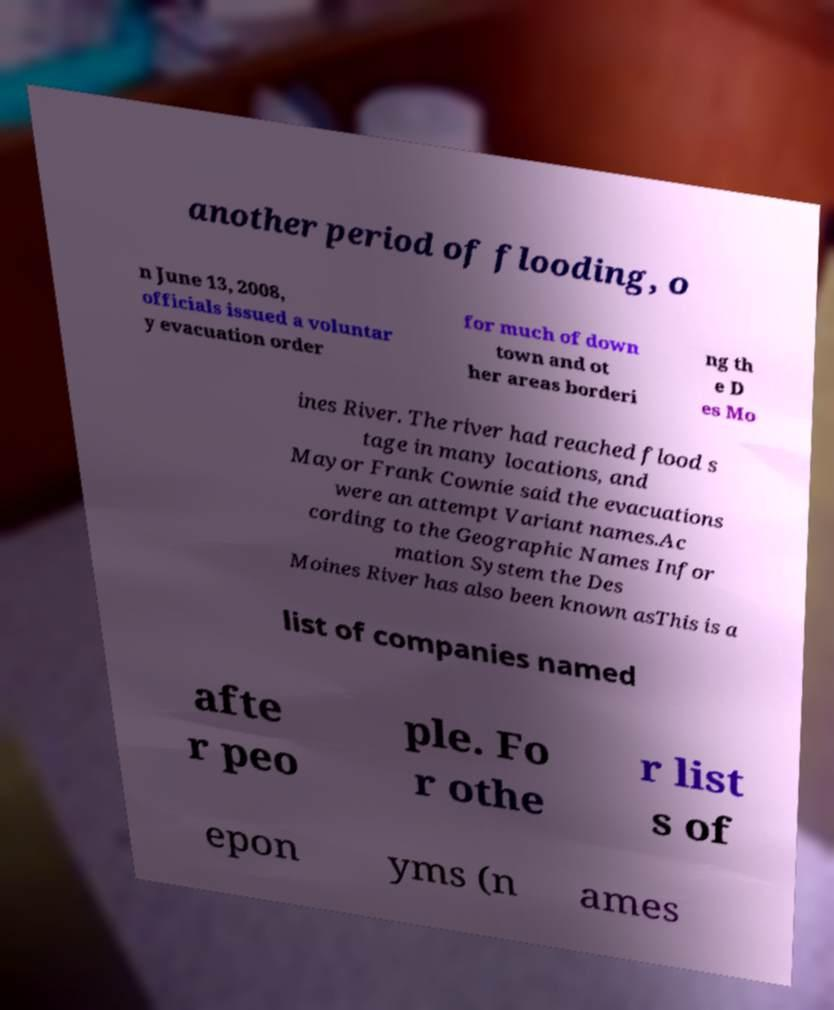Please identify and transcribe the text found in this image. another period of flooding, o n June 13, 2008, officials issued a voluntar y evacuation order for much of down town and ot her areas borderi ng th e D es Mo ines River. The river had reached flood s tage in many locations, and Mayor Frank Cownie said the evacuations were an attempt Variant names.Ac cording to the Geographic Names Infor mation System the Des Moines River has also been known asThis is a list of companies named afte r peo ple. Fo r othe r list s of epon yms (n ames 